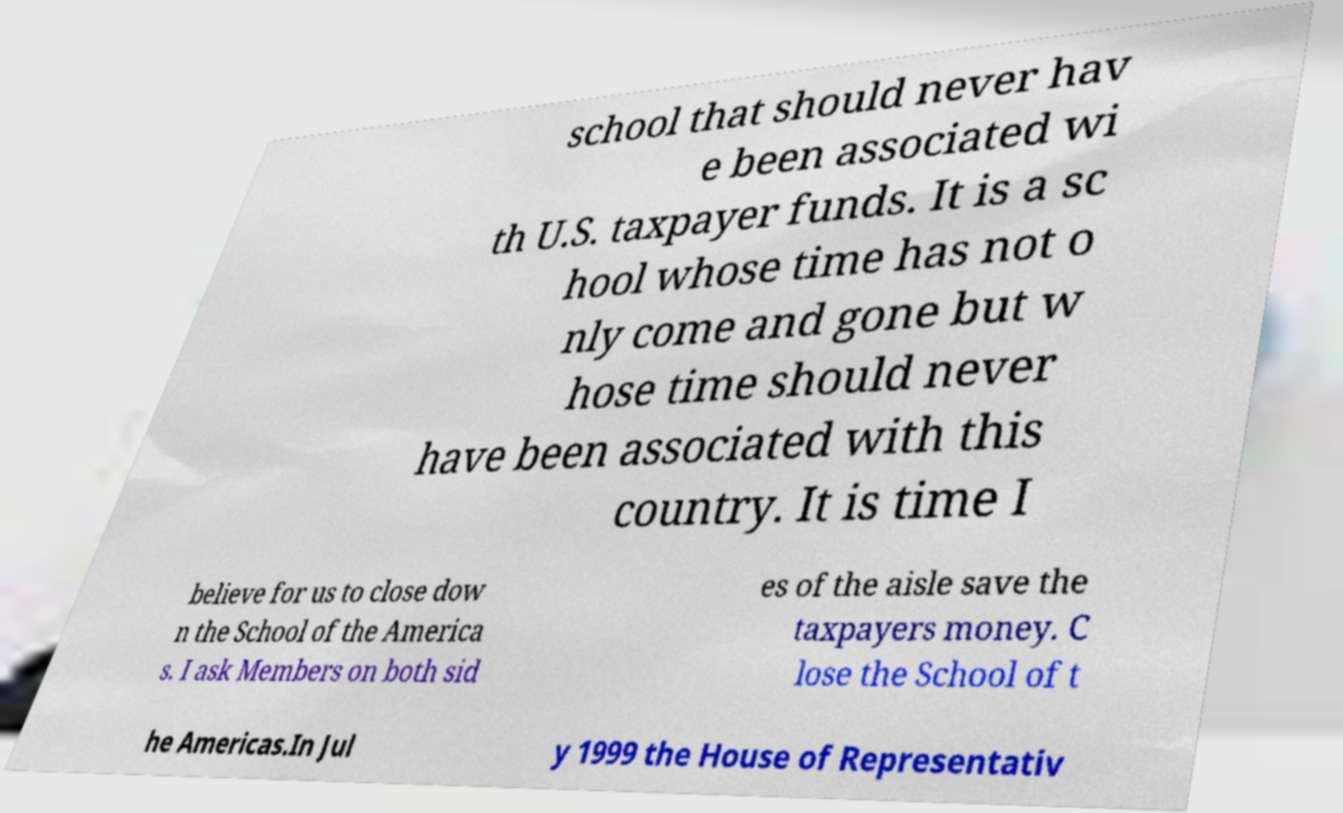Can you accurately transcribe the text from the provided image for me? school that should never hav e been associated wi th U.S. taxpayer funds. It is a sc hool whose time has not o nly come and gone but w hose time should never have been associated with this country. It is time I believe for us to close dow n the School of the America s. I ask Members on both sid es of the aisle save the taxpayers money. C lose the School of t he Americas.In Jul y 1999 the House of Representativ 